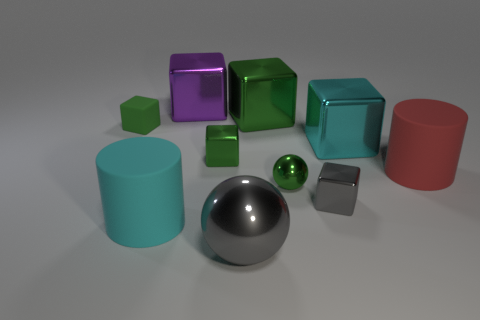Subtract all gray balls. How many green cubes are left? 3 Subtract all cyan cubes. How many cubes are left? 5 Subtract 2 blocks. How many blocks are left? 4 Subtract all large green cubes. How many cubes are left? 5 Subtract all yellow cubes. Subtract all green balls. How many cubes are left? 6 Subtract all cylinders. How many objects are left? 8 Subtract all purple shiny cubes. Subtract all big cylinders. How many objects are left? 7 Add 8 big red cylinders. How many big red cylinders are left? 9 Add 1 shiny balls. How many shiny balls exist? 3 Subtract 0 blue cylinders. How many objects are left? 10 